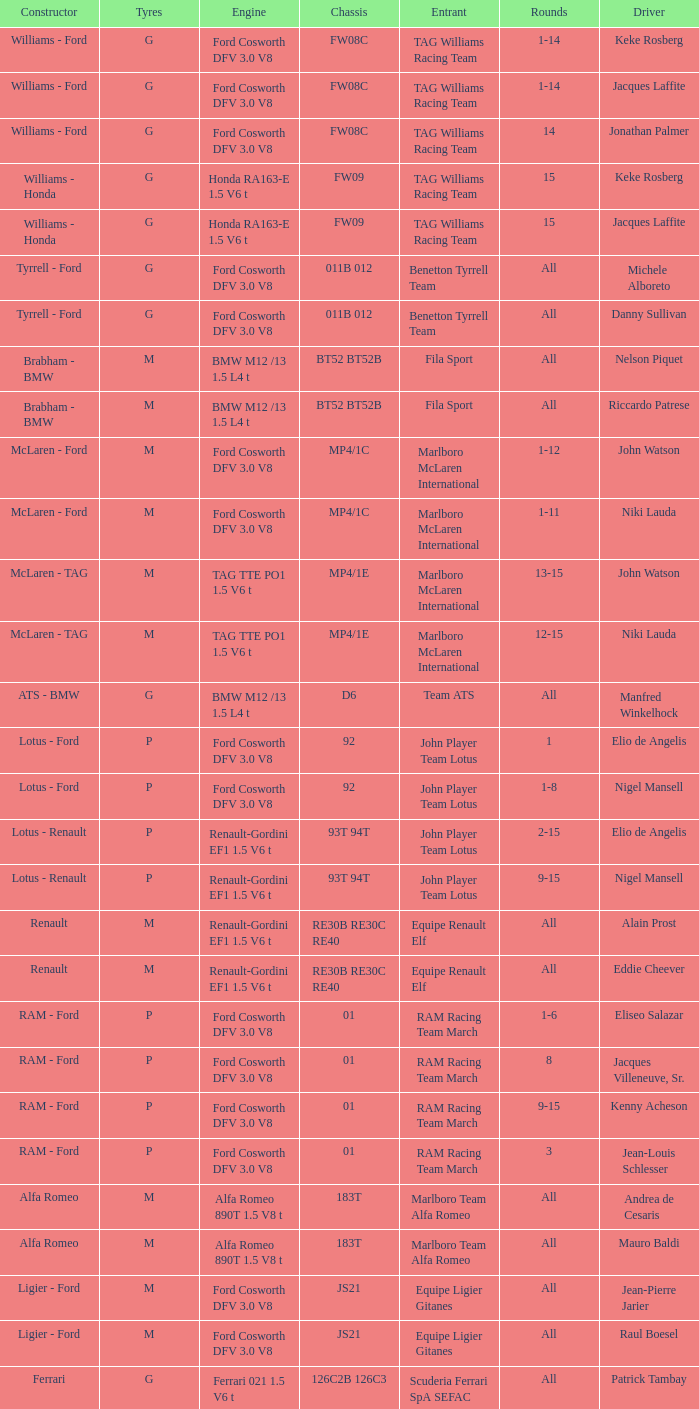Who is the constructor for driver Niki Lauda and a chassis of mp4/1c? McLaren - Ford. 